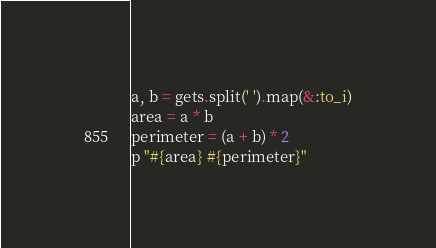<code> <loc_0><loc_0><loc_500><loc_500><_Ruby_>a, b = gets.split(' ').map(&:to_i)
area = a * b
perimeter = (a + b) * 2
p "#{area} #{perimeter}"</code> 